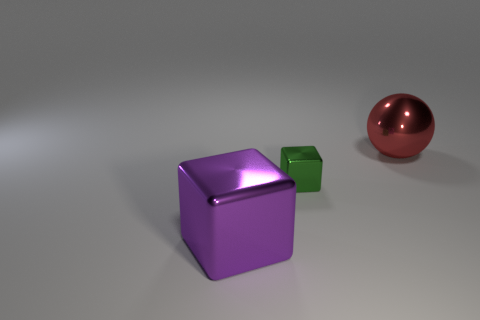What does the lighting in this image suggest about the environment? The soft shadowing and diffused light suggest an indoor setting with ambient lighting, possibly a studio environment where the objects are being spotlighted for a clear view. 